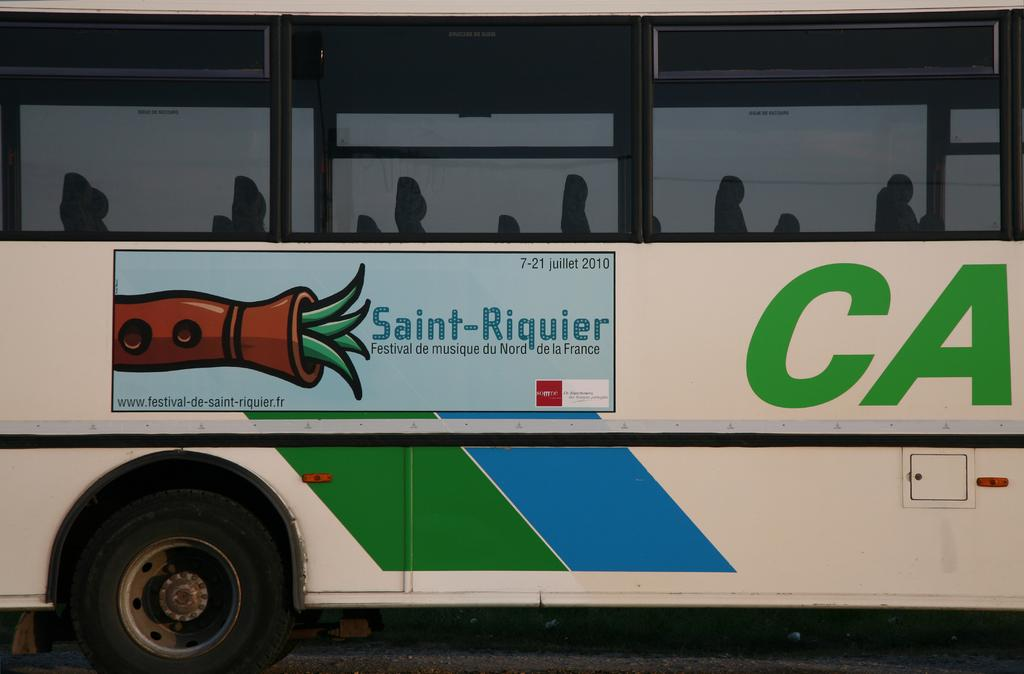What is the main subject of the image? The main subject of the image is a bus. Where is the bus located in the image? The bus is on the road in the image. What can be seen on the exterior of the bus? There is a poster on the bus. What is inside the bus? There are seats inside the bus. How many tomatoes are on the seats inside the bus? There are no tomatoes present in the image, and therefore none can be found on the seats inside the bus. 